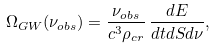<formula> <loc_0><loc_0><loc_500><loc_500>\Omega _ { G W } ( \nu _ { o b s } ) = \frac { \nu _ { o b s } } { c ^ { 3 } \rho _ { c r } } \, \frac { d E } { d t d S d \nu } ,</formula> 